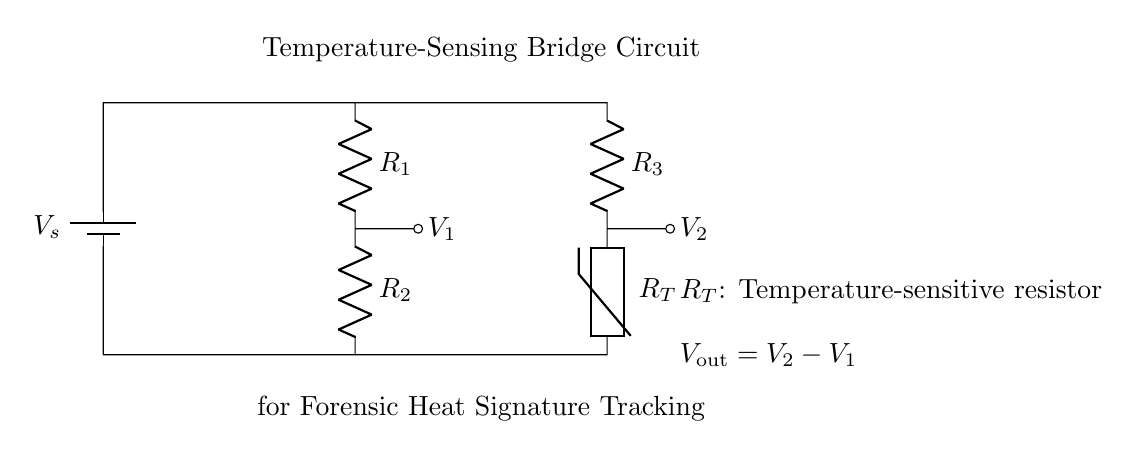What are the two types of resistors in the circuit? The circuit contains two types of resistors: a fixed resistor denoted by R1 and R2, and a temperature-sensitive resistor denoted by R_T.
Answer: R1, R2, R_T What does V_out represent in this circuit? V_out is defined as the difference between the voltages at the two nodes, V2 and V1, representing the output voltage of the bridge circuit that indicates temperature changes.
Answer: V_out = V2 - V1 What is the purpose of the thermistor in this circuit? The thermistor (R_T) changes its resistance based on temperature, allowing the bridge circuit to measure variations in heat signatures crucial for forensic investigations.
Answer: Measure temperature How are the resistors connected in the circuit? The resistors R1 and R2 are connected in series on one leg of the bridge circuit, while R3 and the thermistor R_T are connected in series on the opposite leg, creating a balanced bridge.
Answer: Series connection What is the significance of the battery in the circuit? The battery provides the necessary voltage supply (Vs) for the circuit to operate, creating the potential difference needed to detect changes in resistance and derive temperature readings.
Answer: Voltage supply How does the circuit detect temperature changes? By monitoring the output voltage V_out, which changes with variations in resistance due to temperature-induced changes in the thermistor, the circuit can detect heat signatures.
Answer: By measuring V_out 